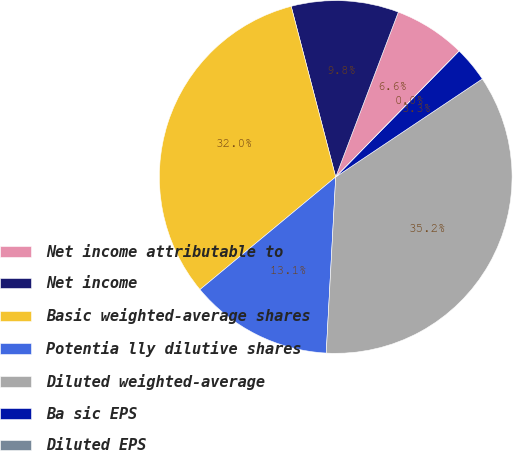Convert chart to OTSL. <chart><loc_0><loc_0><loc_500><loc_500><pie_chart><fcel>Net income attributable to<fcel>Net income<fcel>Basic weighted-average shares<fcel>Potentia lly dilutive shares<fcel>Diluted weighted-average<fcel>Ba sic EPS<fcel>Diluted EPS<nl><fcel>6.56%<fcel>9.84%<fcel>31.96%<fcel>13.12%<fcel>35.24%<fcel>3.28%<fcel>0.0%<nl></chart> 